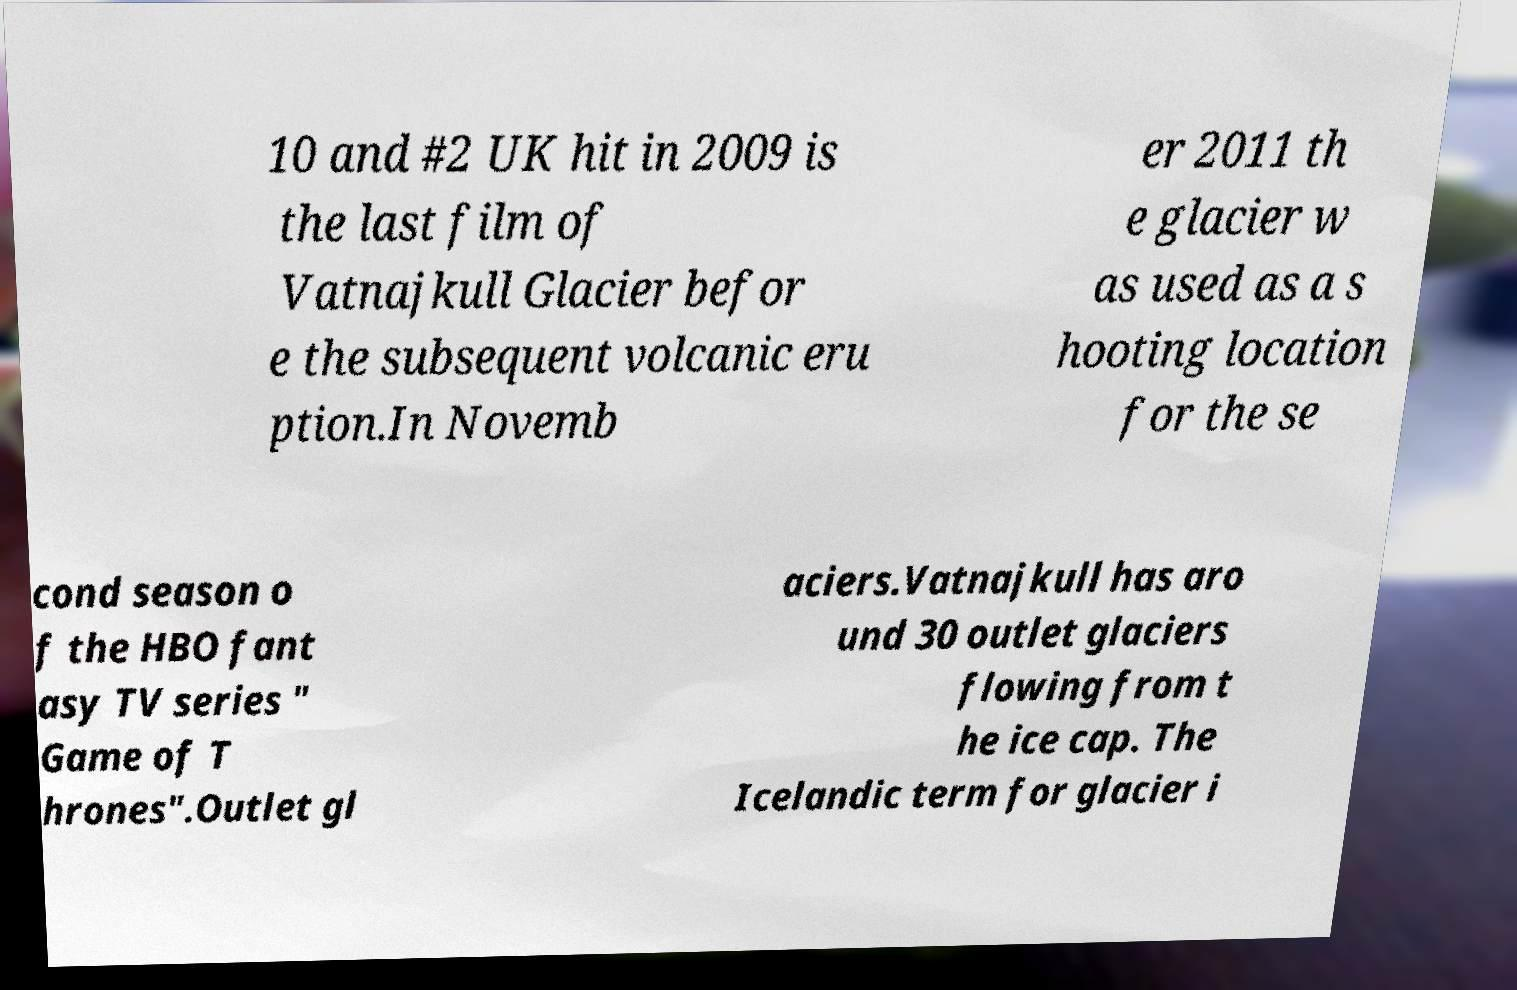Can you read and provide the text displayed in the image?This photo seems to have some interesting text. Can you extract and type it out for me? 10 and #2 UK hit in 2009 is the last film of Vatnajkull Glacier befor e the subsequent volcanic eru ption.In Novemb er 2011 th e glacier w as used as a s hooting location for the se cond season o f the HBO fant asy TV series " Game of T hrones".Outlet gl aciers.Vatnajkull has aro und 30 outlet glaciers flowing from t he ice cap. The Icelandic term for glacier i 